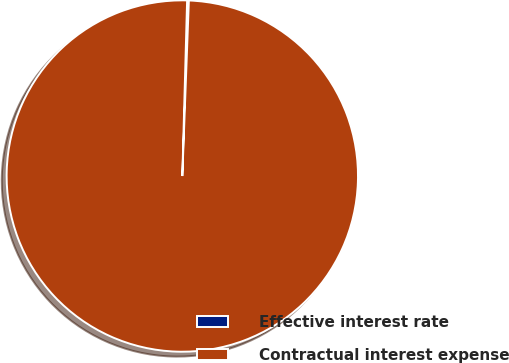Convert chart. <chart><loc_0><loc_0><loc_500><loc_500><pie_chart><fcel>Effective interest rate<fcel>Contractual interest expense<nl><fcel>0.16%<fcel>99.84%<nl></chart> 